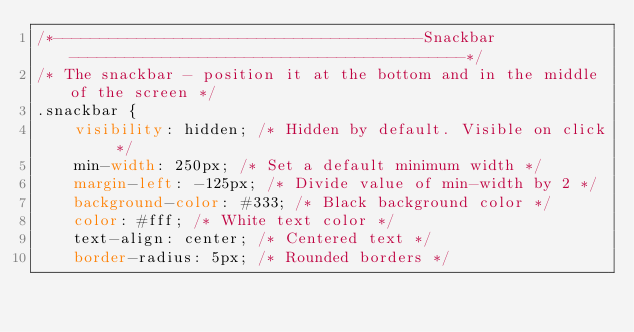Convert code to text. <code><loc_0><loc_0><loc_500><loc_500><_CSS_>/*----------------------------------------Snackbar-------------------------------------------*/
/* The snackbar - position it at the bottom and in the middle of the screen */
.snackbar {
    visibility: hidden; /* Hidden by default. Visible on click */
    min-width: 250px; /* Set a default minimum width */
    margin-left: -125px; /* Divide value of min-width by 2 */
    background-color: #333; /* Black background color */
    color: #fff; /* White text color */
    text-align: center; /* Centered text */
    border-radius: 5px; /* Rounded borders */</code> 